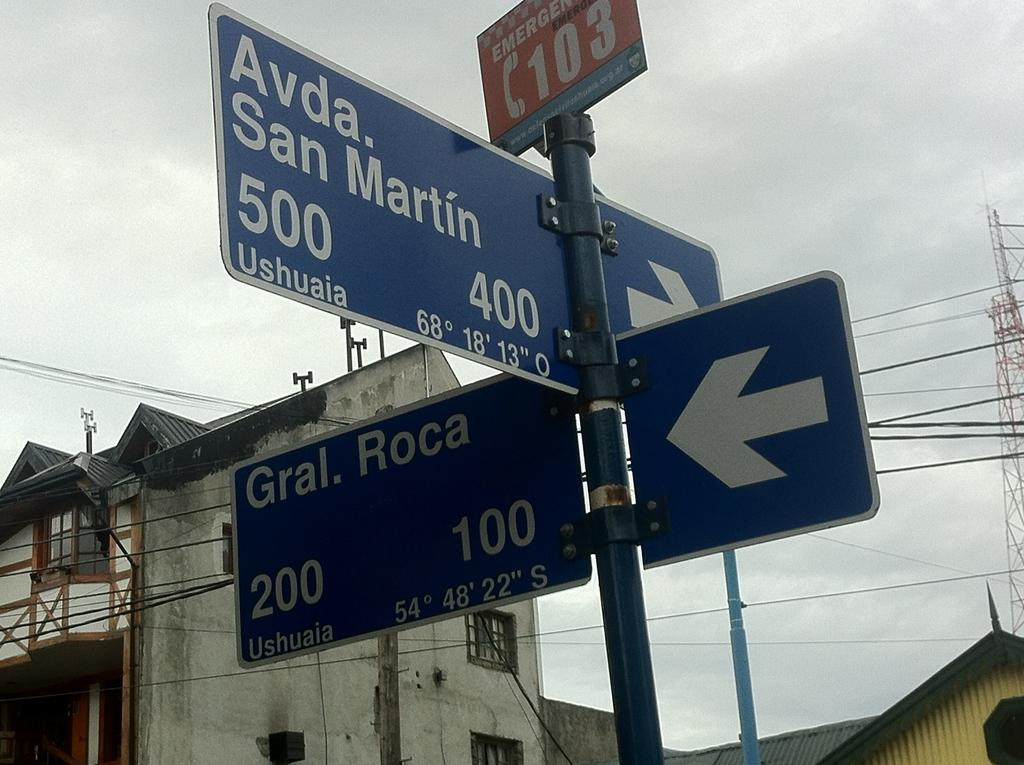<image>
Create a compact narrative representing the image presented. A street sign is located at the intersection of Gral. Roca and Avda. San Martin. 